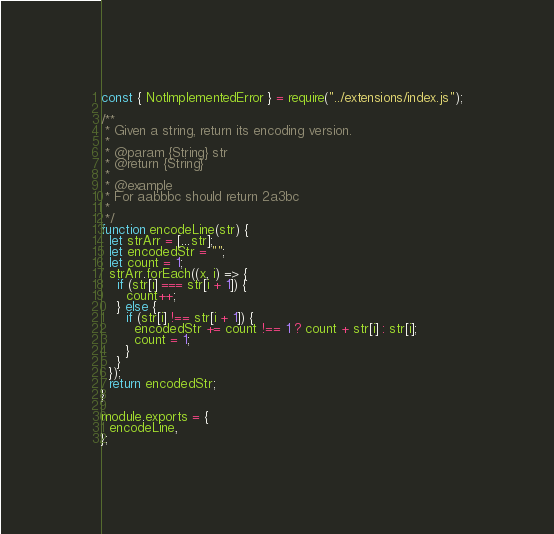Convert code to text. <code><loc_0><loc_0><loc_500><loc_500><_JavaScript_>const { NotImplementedError } = require("../extensions/index.js");

/**
 * Given a string, return its encoding version.
 *
 * @param {String} str
 * @return {String}
 *
 * @example
 * For aabbbc should return 2a3bc
 *
 */
function encodeLine(str) {
  let strArr = [...str];
  let encodedStr = "";
  let count = 1;
  strArr.forEach((x, i) => {
    if (str[i] === str[i + 1]) {
      count++;
    } else {
      if (str[i] !== str[i + 1]) {
        encodedStr += count !== 1 ? count + str[i] : str[i];
        count = 1;
      }
    }
  });
  return encodedStr;
}

module.exports = {
  encodeLine,
};
</code> 